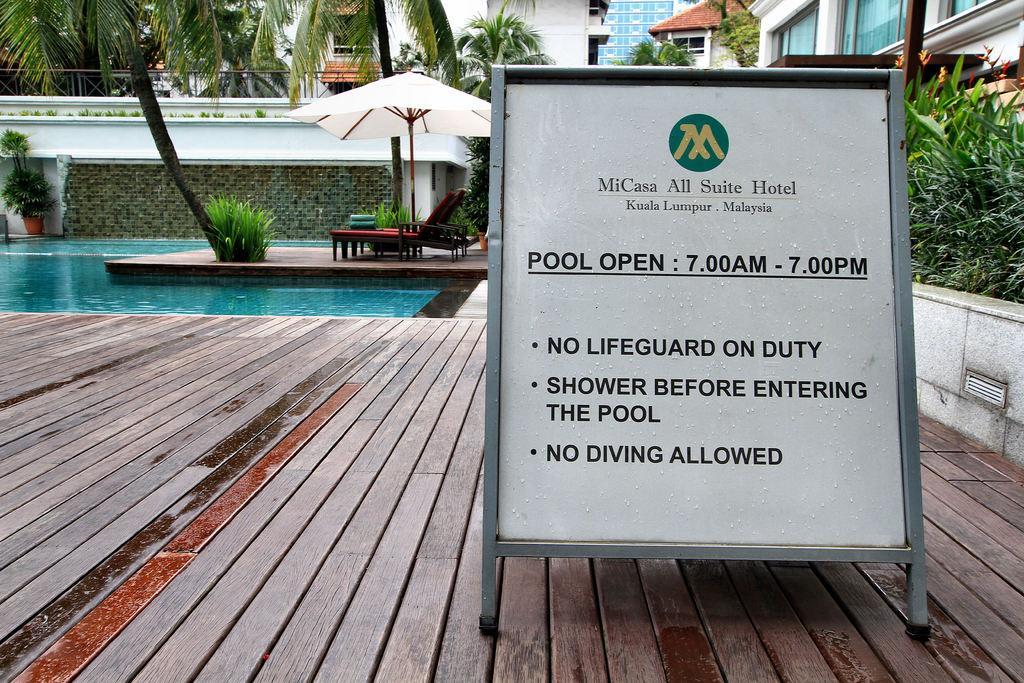In one or two sentences, can you explain what this image depicts? This picture is clicked outside. In the foreground we can see the text and numbers on the board which is attached to the metal rods and we can see the wooden planks, water body, potted plants and we can see the chair and an umbrella. In the background we can see the buildings, trees, plants and some other items. 